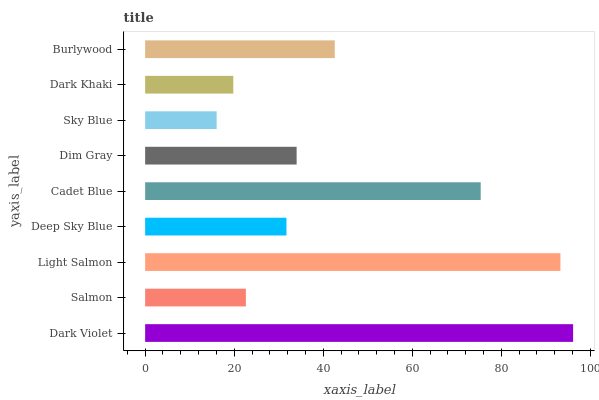Is Sky Blue the minimum?
Answer yes or no. Yes. Is Dark Violet the maximum?
Answer yes or no. Yes. Is Salmon the minimum?
Answer yes or no. No. Is Salmon the maximum?
Answer yes or no. No. Is Dark Violet greater than Salmon?
Answer yes or no. Yes. Is Salmon less than Dark Violet?
Answer yes or no. Yes. Is Salmon greater than Dark Violet?
Answer yes or no. No. Is Dark Violet less than Salmon?
Answer yes or no. No. Is Dim Gray the high median?
Answer yes or no. Yes. Is Dim Gray the low median?
Answer yes or no. Yes. Is Light Salmon the high median?
Answer yes or no. No. Is Light Salmon the low median?
Answer yes or no. No. 